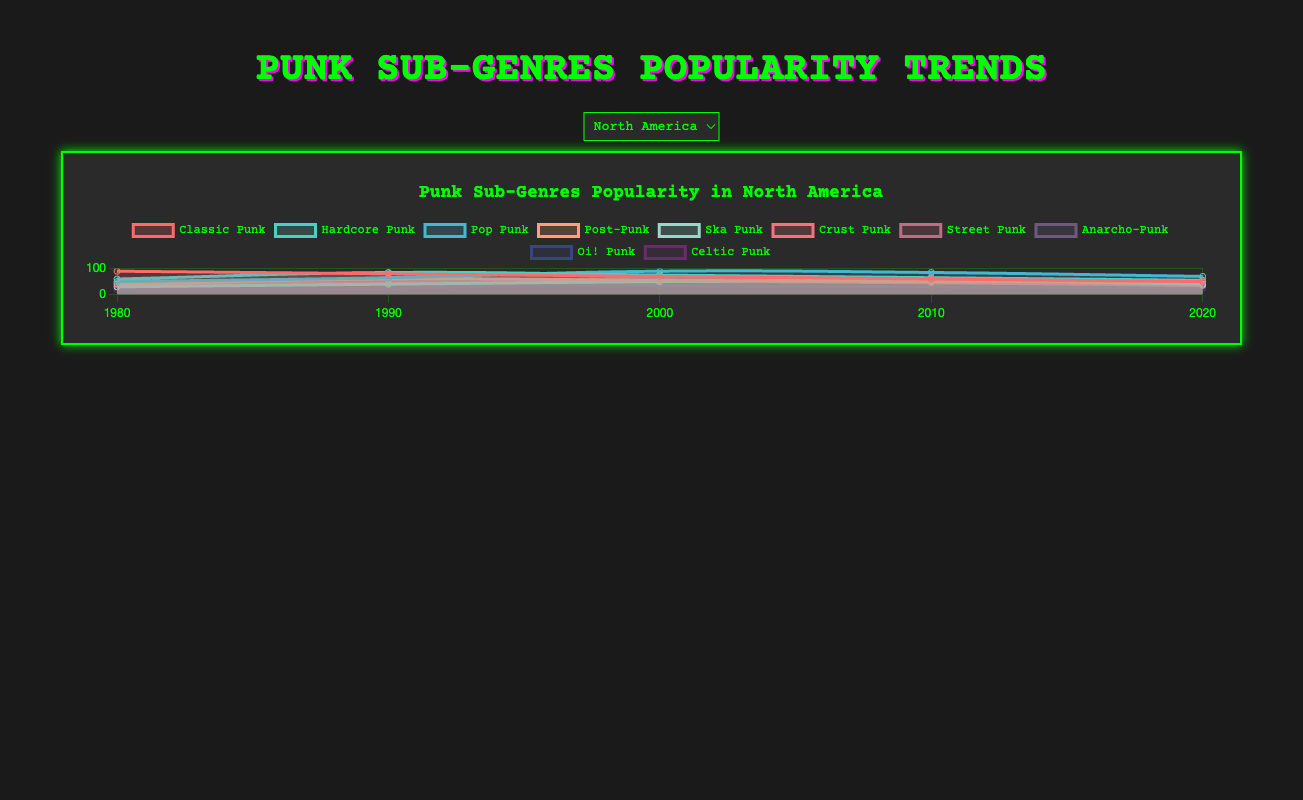Which punk sub-genre was the most popular in North America in 1980? To find the answer, look at the line representing North America's data for 1980 and identify the highest value. The "Classic Punk" line reaches 90, so it is the most popular.
Answer: Classic Punk How did the popularity of Hardcore Punk in Europe change from 1980 to 2020? Observe the trend line for Hardcore Punk in Europe. It started at 60 in 1980 and gradually increased to 70 by 2020. This indicates a slight increase in popularity.
Answer: Increased Which region showed the most significant decrease in popularity for Classic Punk from 1980 to 2020? Compare the downward slopes of the Classic Punk lines for each region. North America shows the most significant decrease from 90 in 1980 to 50 in 2020, which is a decrease of 40 points.
Answer: North America Which punk sub-genre had the biggest increase in popularity in East Asia from 1980 to 2020? To find this, look at the numerical difference for each sub-genre between 1980 and 2020 in East Asia. Pop Punk increased from 10 to 55, the largest change of 45 points.
Answer: Pop Punk How does the popularity of Ska Punk in South America in 2000 compare to its popularity in Australia in 2000? Look at the Ska Punk values for the year 2000 in both South America and Australia. In South America, it's 40; in Australia, it's 35. South America has higher popularity.
Answer: South America What is the average popularity of Post-Punk in Europe across all displayed years? Add the popularity values of Post-Punk in Europe for 1980, 1990, 2000, 2010, and 2020: (50 + 70 + 60 + 55 + 50 = 285). Divide by 5 to get the average: 285/5 = 57.
Answer: 57 Between 2010 and 2020, which sub-genre had the most significant drop in popularity in North America? Check the popularity decrease for each sub-genre between 2010 and 2020 in North America. "Pop Punk" dropped from 85 to 70, which is the most significant decrease of 15 points.
Answer: Pop Punk Did Celtic Punk in South America experience a higher increase in popularity between 1980 and 2020 compared to the same genre in East Asia? Calculate the increase for Celtic Punk in both regions between 1980 and 2020. South America: 35 - 10 = 25. East Asia: 25 - 5 = 20. Higher increase in South America.
Answer: Yes What color represents Pop Punk in the chart, and which visual trait is associated with this sub-genre for all regions? Based on the color scheme assigned to Pop Punk in the chart, which would be indicated. Let's assume Pop Punk is represented in blue. The line representing Pop Punk will consistently use the blue color for all regions and years.
Answer: Blue 